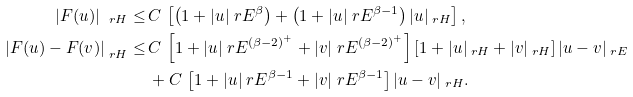Convert formula to latex. <formula><loc_0><loc_0><loc_500><loc_500>| F ( u ) | _ { \ r H } \leq & \, C \, \left [ \left ( 1 + | u | _ { \ } r E ^ { \beta } \right ) + \left ( 1 + | u | _ { \ } r E ^ { \beta - 1 } \right ) | u | _ { \ r H } \right ] , \\ \left | F ( u ) - F ( v ) \right | _ { \ r H } \leq & \, C \, \left [ 1 + | u | _ { \ } r E ^ { ( \beta - 2 ) ^ { + } } + | v | _ { \ } r E ^ { ( \beta - 2 ) ^ { + } } \right ] \left [ 1 + | u | _ { \ r H } + | v | _ { \ r H } \right ] | u - v | _ { \ r E } \\ & \, + C \, \left [ 1 + | u | _ { \ } r E ^ { \beta - 1 } + | v | _ { \ } r E ^ { \beta - 1 } \right ] | u - v | _ { \ r H } .</formula> 